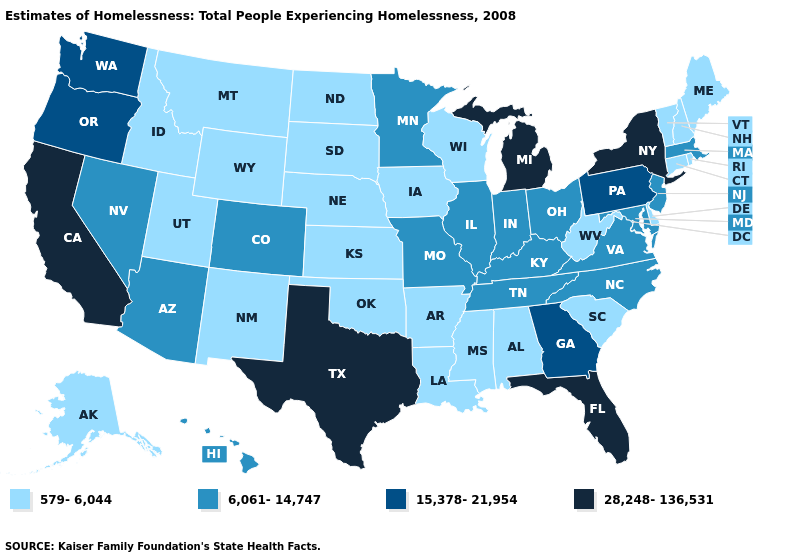Name the states that have a value in the range 28,248-136,531?
Write a very short answer. California, Florida, Michigan, New York, Texas. Does the map have missing data?
Give a very brief answer. No. Name the states that have a value in the range 15,378-21,954?
Quick response, please. Georgia, Oregon, Pennsylvania, Washington. What is the value of Utah?
Concise answer only. 579-6,044. Among the states that border Indiana , which have the lowest value?
Concise answer only. Illinois, Kentucky, Ohio. Which states have the highest value in the USA?
Answer briefly. California, Florida, Michigan, New York, Texas. What is the lowest value in the MidWest?
Write a very short answer. 579-6,044. What is the lowest value in the MidWest?
Answer briefly. 579-6,044. Name the states that have a value in the range 28,248-136,531?
Give a very brief answer. California, Florida, Michigan, New York, Texas. What is the value of Vermont?
Write a very short answer. 579-6,044. What is the value of Oklahoma?
Concise answer only. 579-6,044. Among the states that border New York , does Vermont have the lowest value?
Quick response, please. Yes. Name the states that have a value in the range 15,378-21,954?
Answer briefly. Georgia, Oregon, Pennsylvania, Washington. What is the value of Idaho?
Quick response, please. 579-6,044. Does the map have missing data?
Answer briefly. No. 